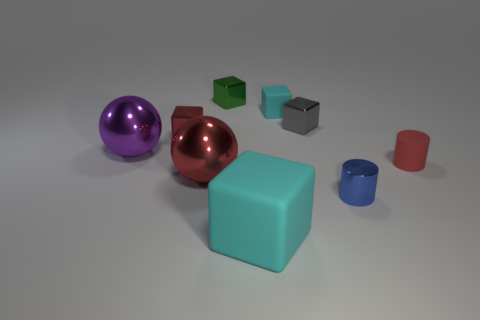Could you describe the texture and material of the objects in the image? Sure! There are multiple objects with different textures. The purple and copper spheres seem to have a smooth and shiny metallic surface. The large blue cube and the small gray cubes look a bit matte, suggesting a plastic or rubberized texture. The red cube appears somewhat glossy, which might indicate a painted wooden material, while the tiny red cylinder and the blue hollow cylinder have a matte finish, also suggesting a plastic or rubber material. 